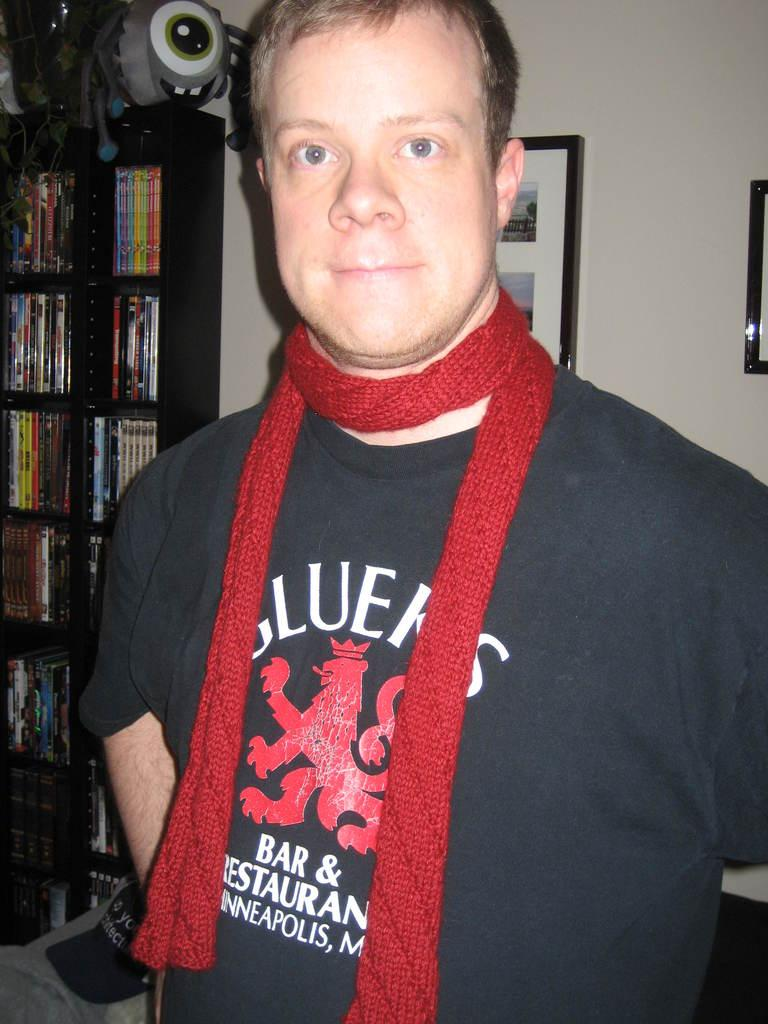Provide a one-sentence caption for the provided image. A man in a red scard with the word bar and restaurant on his tee shirt. 